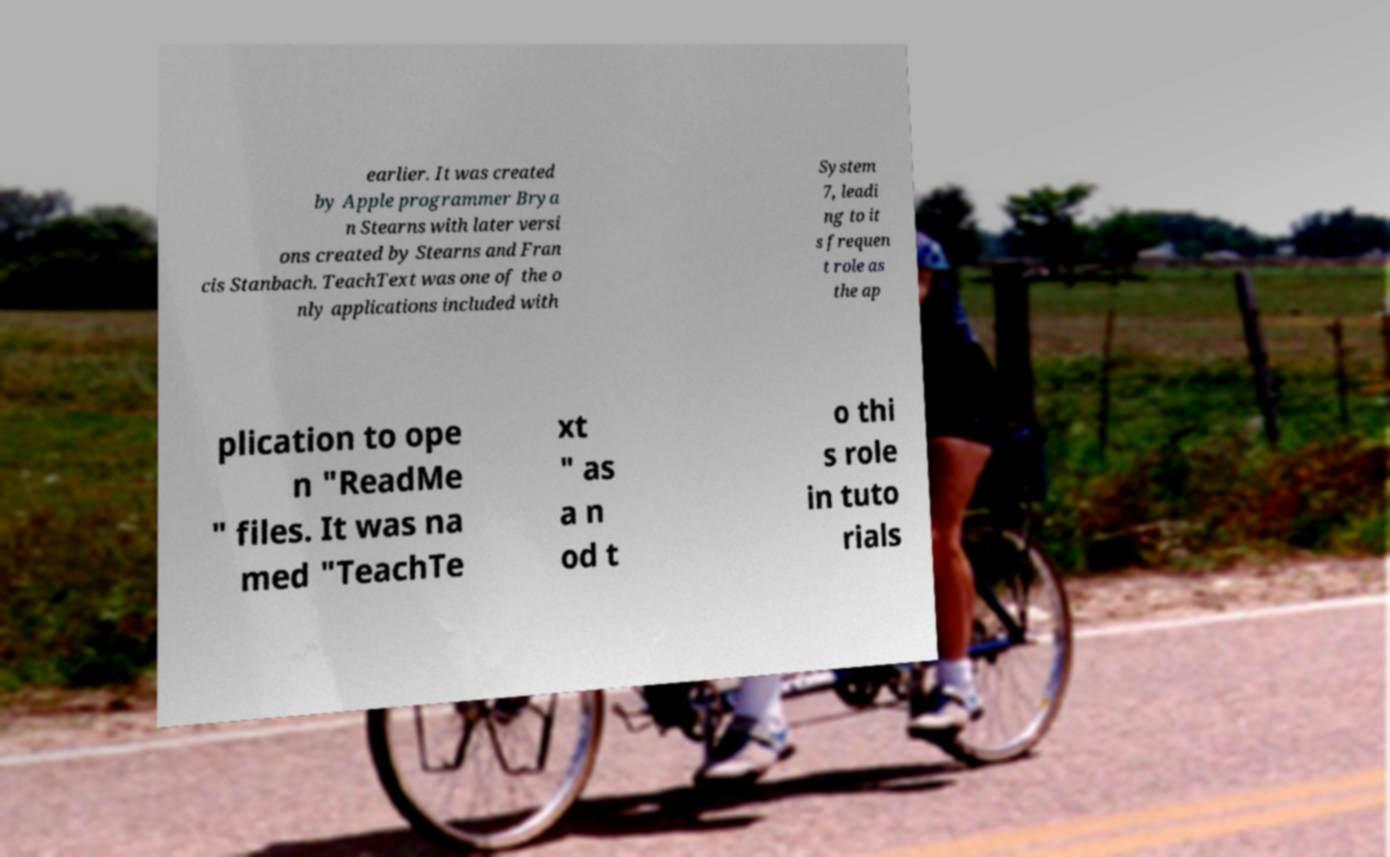Please read and relay the text visible in this image. What does it say? earlier. It was created by Apple programmer Brya n Stearns with later versi ons created by Stearns and Fran cis Stanbach. TeachText was one of the o nly applications included with System 7, leadi ng to it s frequen t role as the ap plication to ope n "ReadMe " files. It was na med "TeachTe xt " as a n od t o thi s role in tuto rials 